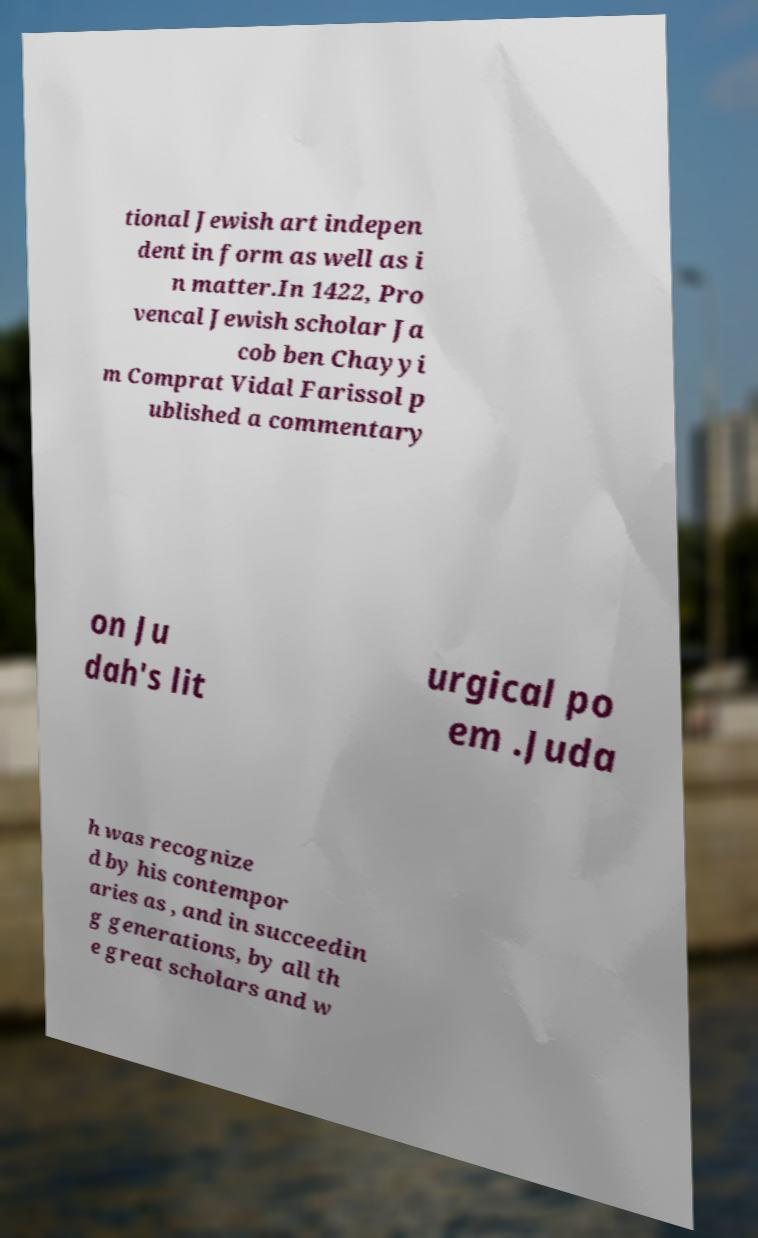For documentation purposes, I need the text within this image transcribed. Could you provide that? tional Jewish art indepen dent in form as well as i n matter.In 1422, Pro vencal Jewish scholar Ja cob ben Chayyi m Comprat Vidal Farissol p ublished a commentary on Ju dah's lit urgical po em .Juda h was recognize d by his contempor aries as , and in succeedin g generations, by all th e great scholars and w 